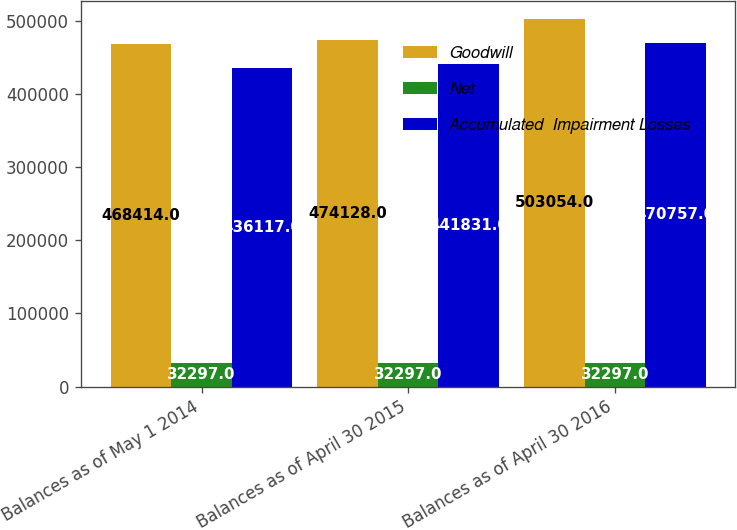Convert chart to OTSL. <chart><loc_0><loc_0><loc_500><loc_500><stacked_bar_chart><ecel><fcel>Balances as of May 1 2014<fcel>Balances as of April 30 2015<fcel>Balances as of April 30 2016<nl><fcel>Goodwill<fcel>468414<fcel>474128<fcel>503054<nl><fcel>Net<fcel>32297<fcel>32297<fcel>32297<nl><fcel>Accumulated  Impairment Losses<fcel>436117<fcel>441831<fcel>470757<nl></chart> 